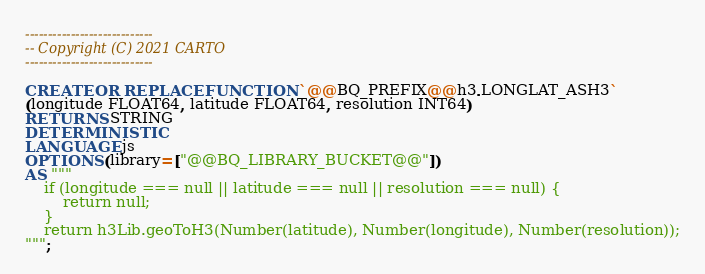Convert code to text. <code><loc_0><loc_0><loc_500><loc_500><_SQL_>----------------------------
-- Copyright (C) 2021 CARTO
----------------------------

CREATE OR REPLACE FUNCTION `@@BQ_PREFIX@@h3.LONGLAT_ASH3`
(longitude FLOAT64, latitude FLOAT64, resolution INT64)
RETURNS STRING
DETERMINISTIC
LANGUAGE js
OPTIONS (library=["@@BQ_LIBRARY_BUCKET@@"])
AS """
    if (longitude === null || latitude === null || resolution === null) {
        return null;
    }
    return h3Lib.geoToH3(Number(latitude), Number(longitude), Number(resolution));
""";</code> 